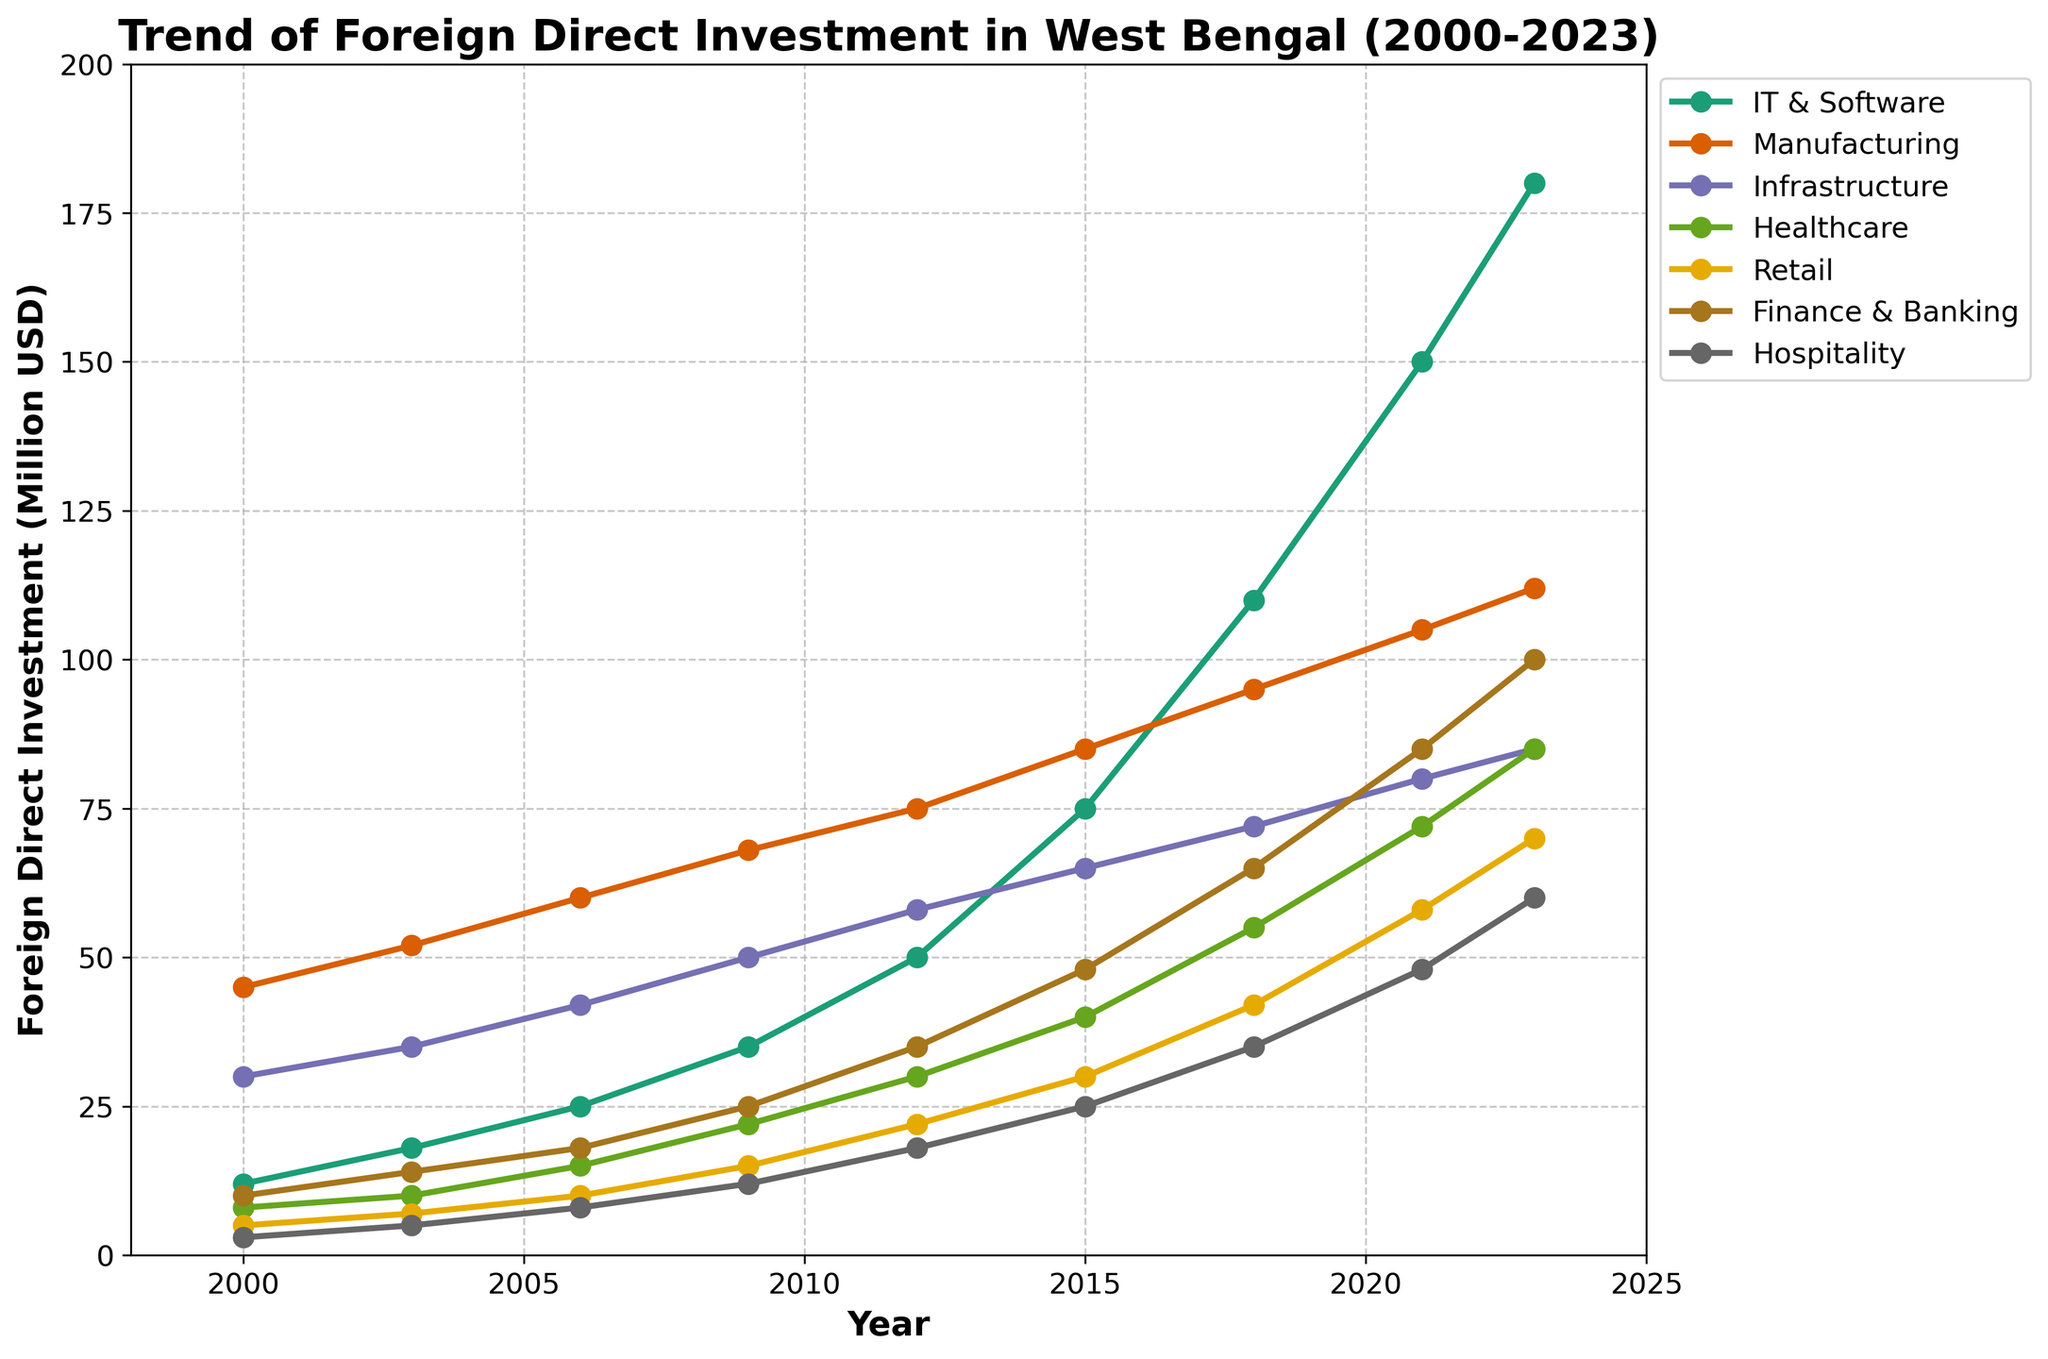What is the trend of FDI in the IT & Software sector from 2000 to 2023? The trend shows a steady increase in FDI in the IT & Software sector from 12 million USD in 2000 to 180 million USD in 2023.
Answer: Steady increase Which sector had the highest FDI in 2023? By looking at the rightmost points of each line, the IT & Software sector had the highest FDI in 2023, with 180 million USD.
Answer: IT & Software By how much did the FDI in Manufacturing increase from 2000 to 2023? FDI in Manufacturing was 45 million USD in 2000 and increased to 112 million USD in 2023. The difference is 112 - 45 = 67 million USD.
Answer: 67 million USD Compare the FDI trends in Healthcare and Retail from 2006 to 2023. Which sector had faster growth? In 2006, Healthcare FDI was 15 million USD, and Retail was 10 million USD. By 2023, Healthcare FDI grew to 85 million USD, and Retail to 70 million USD. The growth for Healthcare is 85 - 15 = 70 million USD, and for Retail 70 - 10 = 60 million USD. Healthcare had faster growth.
Answer: Healthcare Which sector experienced the most significant boost in FDI between 2018 and 2021? Between 2018 and 2021, IT & Software FDI increased from 110 million USD to 150 million USD, Manufacturing from 95 million USD to 105 million USD, and so on. The IT & Software sector experienced the most significant boost with an increase of 40 million USD.
Answer: IT & Software What is the average FDI in Infrastructure from 2000 to 2023? The FDI values for Infrastructure from 2000 to 2023 are 30, 35, 42, 50, 58, 65, 72, 80, 85. Adding these gives 517. Dividing by the number of data points (9), the average FDI is 517 / 9 ≈ 57.44 million USD.
Answer: 57.44 million USD How does the FDI trend in Finance & Banking compare to Hospitality from 2000 to 2023? From 2000 to 2023, FDI in Finance & Banking grew from 10 million USD to 100 million USD, and Hospitality grew from 3 million USD to 60 million USD. Both sectors grew significantly, but Finance & Banking saw higher FDI amounts in all years and a greater overall increase.
Answer: Finance & Banking grew more Identify the year with the largest increase in FDI in the Healthcare sector. Comparing subsequent years, the biggest jump in Healthcare FDI occurred between 2018 (55 million USD) and 2021 (72 million USD), with an increase of 17 million USD.
Answer: 2018 to 2021 Which sector had the slowest growth in FDI from 2000 to 2023? Comparing the growth of all sectors, Hospitality increased from 3 million USD in 2000 to 60 million USD in 2023, the smallest overall increase across all sectors.
Answer: Hospitality 